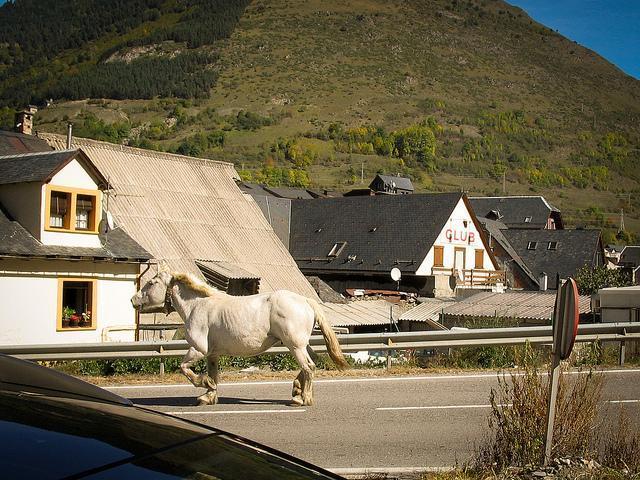How many of the people sitting have a laptop on there lap?
Give a very brief answer. 0. 